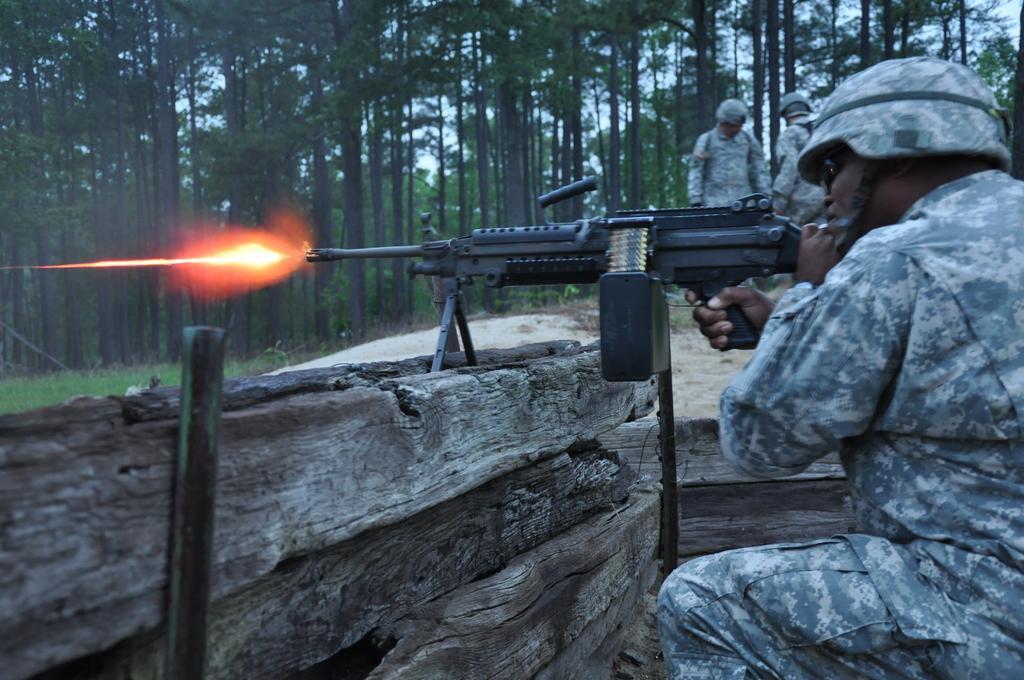How would you summarize this image in a sentence or two? In this image we can see a person using a weapon. He is wearing a helmet. In the background of the image there are trees. There are people standing. To the left side of the image there is wooden wall. 